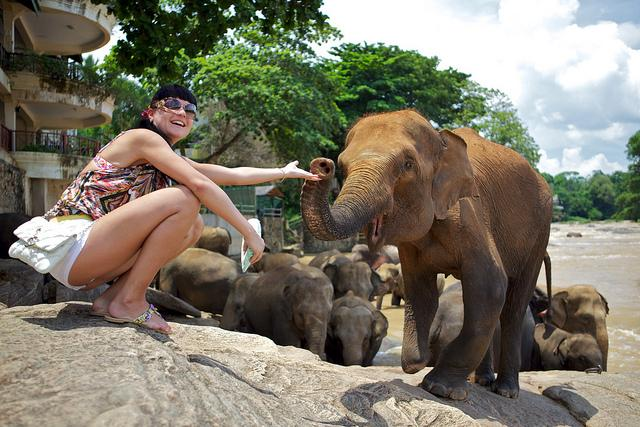What is the woman wearing? shorts 